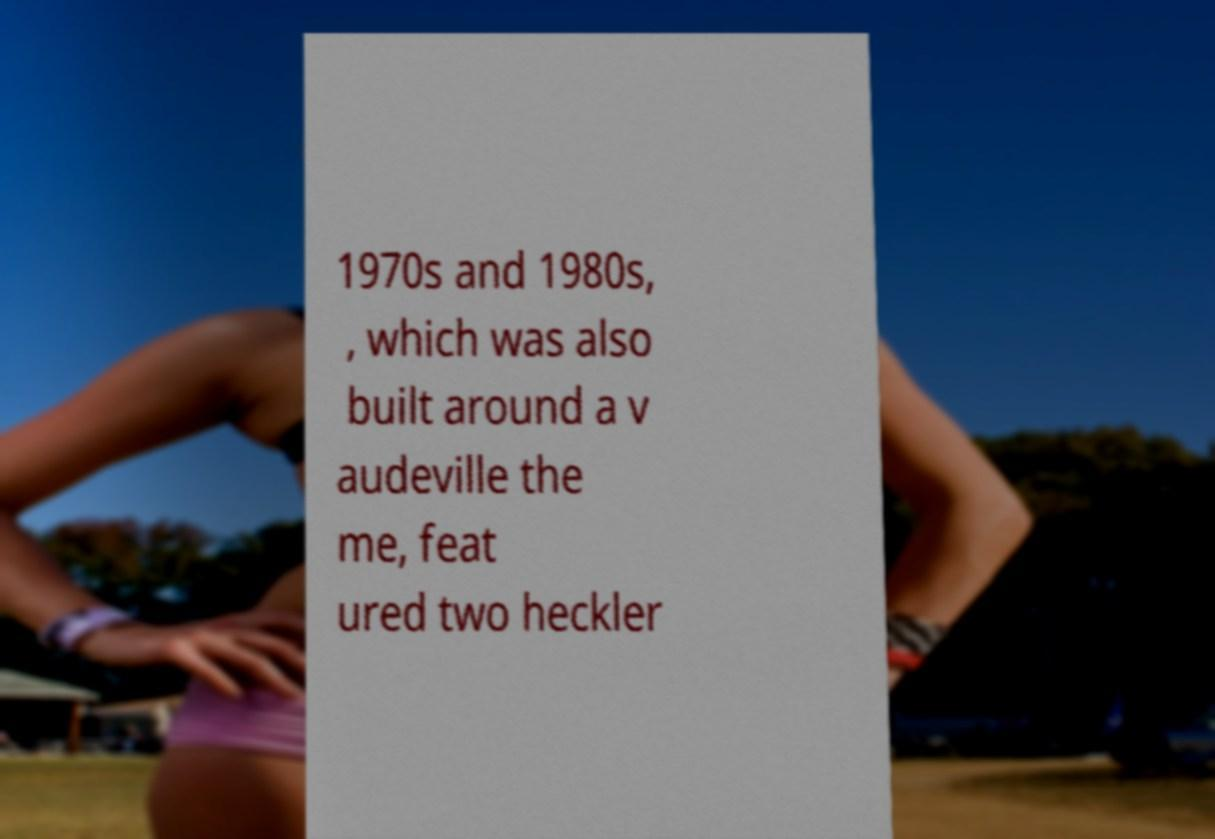I need the written content from this picture converted into text. Can you do that? 1970s and 1980s, , which was also built around a v audeville the me, feat ured two heckler 